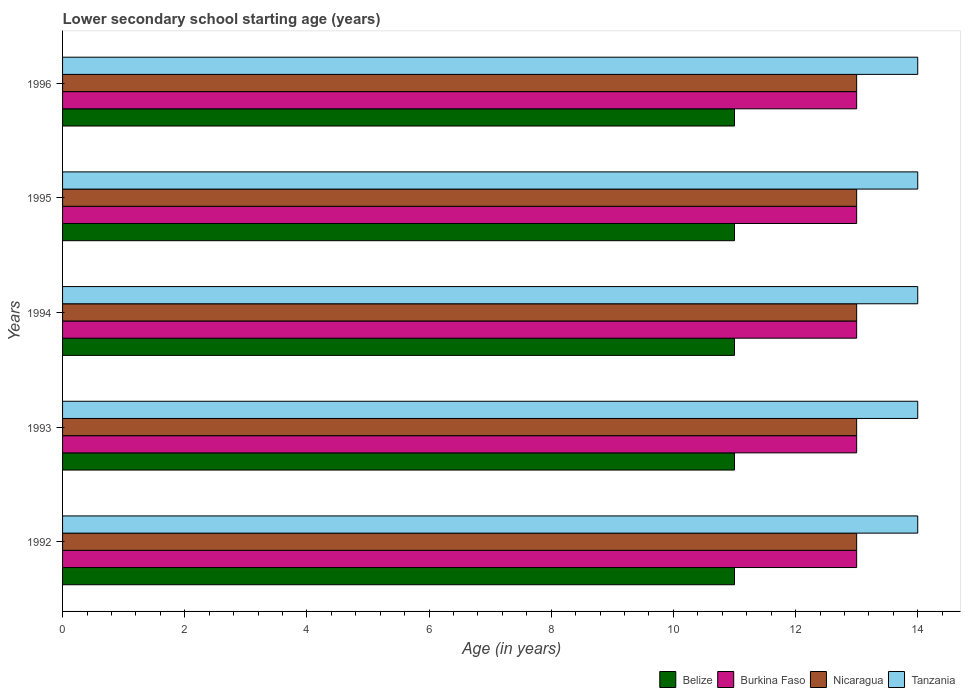How many groups of bars are there?
Your answer should be very brief. 5. Are the number of bars per tick equal to the number of legend labels?
Keep it short and to the point. Yes. Are the number of bars on each tick of the Y-axis equal?
Your response must be concise. Yes. What is the label of the 2nd group of bars from the top?
Ensure brevity in your answer.  1995. What is the lower secondary school starting age of children in Burkina Faso in 1995?
Ensure brevity in your answer.  13. Across all years, what is the maximum lower secondary school starting age of children in Belize?
Keep it short and to the point. 11. Across all years, what is the minimum lower secondary school starting age of children in Nicaragua?
Offer a terse response. 13. In which year was the lower secondary school starting age of children in Burkina Faso maximum?
Provide a succinct answer. 1992. In which year was the lower secondary school starting age of children in Belize minimum?
Your answer should be very brief. 1992. What is the total lower secondary school starting age of children in Nicaragua in the graph?
Offer a terse response. 65. What is the difference between the lower secondary school starting age of children in Belize in 1992 and that in 1994?
Offer a very short reply. 0. What is the difference between the lower secondary school starting age of children in Burkina Faso in 1993 and the lower secondary school starting age of children in Nicaragua in 1996?
Your answer should be very brief. 0. In the year 1995, what is the difference between the lower secondary school starting age of children in Burkina Faso and lower secondary school starting age of children in Tanzania?
Offer a very short reply. -1. What is the ratio of the lower secondary school starting age of children in Belize in 1993 to that in 1994?
Provide a short and direct response. 1. Is the lower secondary school starting age of children in Burkina Faso in 1994 less than that in 1996?
Provide a short and direct response. No. Is the difference between the lower secondary school starting age of children in Burkina Faso in 1993 and 1995 greater than the difference between the lower secondary school starting age of children in Tanzania in 1993 and 1995?
Offer a terse response. No. What is the difference between the highest and the lowest lower secondary school starting age of children in Burkina Faso?
Your answer should be very brief. 0. Is it the case that in every year, the sum of the lower secondary school starting age of children in Nicaragua and lower secondary school starting age of children in Belize is greater than the sum of lower secondary school starting age of children in Tanzania and lower secondary school starting age of children in Burkina Faso?
Ensure brevity in your answer.  No. What does the 3rd bar from the top in 1993 represents?
Offer a very short reply. Burkina Faso. What does the 1st bar from the bottom in 1993 represents?
Keep it short and to the point. Belize. How many bars are there?
Your answer should be very brief. 20. How many years are there in the graph?
Provide a short and direct response. 5. Are the values on the major ticks of X-axis written in scientific E-notation?
Provide a succinct answer. No. Does the graph contain any zero values?
Offer a terse response. No. Does the graph contain grids?
Make the answer very short. No. What is the title of the graph?
Provide a short and direct response. Lower secondary school starting age (years). Does "Yemen, Rep." appear as one of the legend labels in the graph?
Your answer should be compact. No. What is the label or title of the X-axis?
Your answer should be very brief. Age (in years). What is the label or title of the Y-axis?
Your answer should be compact. Years. What is the Age (in years) in Tanzania in 1992?
Make the answer very short. 14. What is the Age (in years) of Belize in 1993?
Ensure brevity in your answer.  11. What is the Age (in years) in Nicaragua in 1993?
Give a very brief answer. 13. What is the Age (in years) of Nicaragua in 1994?
Ensure brevity in your answer.  13. What is the Age (in years) of Nicaragua in 1995?
Your response must be concise. 13. What is the Age (in years) in Tanzania in 1995?
Keep it short and to the point. 14. What is the Age (in years) in Belize in 1996?
Your answer should be compact. 11. What is the Age (in years) of Tanzania in 1996?
Provide a short and direct response. 14. Across all years, what is the maximum Age (in years) of Belize?
Offer a terse response. 11. Across all years, what is the maximum Age (in years) in Nicaragua?
Your answer should be compact. 13. Across all years, what is the maximum Age (in years) of Tanzania?
Make the answer very short. 14. Across all years, what is the minimum Age (in years) of Belize?
Provide a succinct answer. 11. Across all years, what is the minimum Age (in years) of Burkina Faso?
Offer a terse response. 13. Across all years, what is the minimum Age (in years) of Nicaragua?
Offer a very short reply. 13. What is the total Age (in years) of Burkina Faso in the graph?
Give a very brief answer. 65. What is the total Age (in years) of Tanzania in the graph?
Your response must be concise. 70. What is the difference between the Age (in years) of Belize in 1992 and that in 1993?
Provide a succinct answer. 0. What is the difference between the Age (in years) in Tanzania in 1992 and that in 1993?
Provide a succinct answer. 0. What is the difference between the Age (in years) in Nicaragua in 1992 and that in 1994?
Your answer should be very brief. 0. What is the difference between the Age (in years) of Belize in 1992 and that in 1995?
Provide a succinct answer. 0. What is the difference between the Age (in years) of Tanzania in 1992 and that in 1995?
Ensure brevity in your answer.  0. What is the difference between the Age (in years) in Belize in 1992 and that in 1996?
Provide a succinct answer. 0. What is the difference between the Age (in years) in Burkina Faso in 1992 and that in 1996?
Provide a succinct answer. 0. What is the difference between the Age (in years) in Nicaragua in 1992 and that in 1996?
Offer a terse response. 0. What is the difference between the Age (in years) in Tanzania in 1992 and that in 1996?
Your answer should be compact. 0. What is the difference between the Age (in years) in Nicaragua in 1993 and that in 1994?
Provide a short and direct response. 0. What is the difference between the Age (in years) of Burkina Faso in 1993 and that in 1995?
Keep it short and to the point. 0. What is the difference between the Age (in years) in Belize in 1994 and that in 1995?
Ensure brevity in your answer.  0. What is the difference between the Age (in years) of Burkina Faso in 1994 and that in 1995?
Ensure brevity in your answer.  0. What is the difference between the Age (in years) in Nicaragua in 1994 and that in 1995?
Offer a very short reply. 0. What is the difference between the Age (in years) in Belize in 1994 and that in 1996?
Offer a very short reply. 0. What is the difference between the Age (in years) of Tanzania in 1994 and that in 1996?
Ensure brevity in your answer.  0. What is the difference between the Age (in years) of Burkina Faso in 1995 and that in 1996?
Provide a succinct answer. 0. What is the difference between the Age (in years) in Nicaragua in 1995 and that in 1996?
Your answer should be very brief. 0. What is the difference between the Age (in years) of Tanzania in 1995 and that in 1996?
Your answer should be very brief. 0. What is the difference between the Age (in years) in Belize in 1992 and the Age (in years) in Burkina Faso in 1993?
Ensure brevity in your answer.  -2. What is the difference between the Age (in years) of Burkina Faso in 1992 and the Age (in years) of Nicaragua in 1993?
Offer a very short reply. 0. What is the difference between the Age (in years) in Burkina Faso in 1992 and the Age (in years) in Tanzania in 1993?
Your answer should be very brief. -1. What is the difference between the Age (in years) of Belize in 1992 and the Age (in years) of Burkina Faso in 1994?
Make the answer very short. -2. What is the difference between the Age (in years) of Belize in 1992 and the Age (in years) of Tanzania in 1994?
Give a very brief answer. -3. What is the difference between the Age (in years) in Burkina Faso in 1992 and the Age (in years) in Nicaragua in 1994?
Keep it short and to the point. 0. What is the difference between the Age (in years) of Burkina Faso in 1992 and the Age (in years) of Tanzania in 1994?
Your response must be concise. -1. What is the difference between the Age (in years) of Nicaragua in 1992 and the Age (in years) of Tanzania in 1994?
Offer a terse response. -1. What is the difference between the Age (in years) of Burkina Faso in 1992 and the Age (in years) of Tanzania in 1995?
Provide a short and direct response. -1. What is the difference between the Age (in years) in Belize in 1992 and the Age (in years) in Burkina Faso in 1996?
Ensure brevity in your answer.  -2. What is the difference between the Age (in years) of Burkina Faso in 1992 and the Age (in years) of Nicaragua in 1996?
Your answer should be compact. 0. What is the difference between the Age (in years) of Nicaragua in 1992 and the Age (in years) of Tanzania in 1996?
Your answer should be very brief. -1. What is the difference between the Age (in years) of Belize in 1993 and the Age (in years) of Burkina Faso in 1994?
Make the answer very short. -2. What is the difference between the Age (in years) in Belize in 1993 and the Age (in years) in Nicaragua in 1994?
Your answer should be compact. -2. What is the difference between the Age (in years) of Belize in 1993 and the Age (in years) of Tanzania in 1994?
Give a very brief answer. -3. What is the difference between the Age (in years) in Burkina Faso in 1993 and the Age (in years) in Tanzania in 1994?
Give a very brief answer. -1. What is the difference between the Age (in years) of Nicaragua in 1993 and the Age (in years) of Tanzania in 1994?
Keep it short and to the point. -1. What is the difference between the Age (in years) in Belize in 1993 and the Age (in years) in Burkina Faso in 1995?
Offer a terse response. -2. What is the difference between the Age (in years) in Burkina Faso in 1993 and the Age (in years) in Tanzania in 1995?
Provide a succinct answer. -1. What is the difference between the Age (in years) of Nicaragua in 1993 and the Age (in years) of Tanzania in 1995?
Offer a very short reply. -1. What is the difference between the Age (in years) of Belize in 1993 and the Age (in years) of Tanzania in 1996?
Your answer should be compact. -3. What is the difference between the Age (in years) of Burkina Faso in 1993 and the Age (in years) of Nicaragua in 1996?
Make the answer very short. 0. What is the difference between the Age (in years) in Burkina Faso in 1993 and the Age (in years) in Tanzania in 1996?
Give a very brief answer. -1. What is the difference between the Age (in years) of Nicaragua in 1993 and the Age (in years) of Tanzania in 1996?
Your response must be concise. -1. What is the difference between the Age (in years) of Belize in 1994 and the Age (in years) of Burkina Faso in 1995?
Your answer should be compact. -2. What is the difference between the Age (in years) of Belize in 1994 and the Age (in years) of Nicaragua in 1995?
Your answer should be very brief. -2. What is the difference between the Age (in years) of Belize in 1994 and the Age (in years) of Tanzania in 1995?
Provide a succinct answer. -3. What is the difference between the Age (in years) of Belize in 1994 and the Age (in years) of Burkina Faso in 1996?
Your answer should be compact. -2. What is the difference between the Age (in years) of Belize in 1994 and the Age (in years) of Nicaragua in 1996?
Offer a very short reply. -2. What is the difference between the Age (in years) in Belize in 1994 and the Age (in years) in Tanzania in 1996?
Keep it short and to the point. -3. What is the difference between the Age (in years) of Burkina Faso in 1994 and the Age (in years) of Nicaragua in 1996?
Make the answer very short. 0. What is the difference between the Age (in years) of Belize in 1995 and the Age (in years) of Nicaragua in 1996?
Your answer should be very brief. -2. What is the difference between the Age (in years) of Burkina Faso in 1995 and the Age (in years) of Nicaragua in 1996?
Give a very brief answer. 0. What is the difference between the Age (in years) of Burkina Faso in 1995 and the Age (in years) of Tanzania in 1996?
Give a very brief answer. -1. What is the difference between the Age (in years) of Nicaragua in 1995 and the Age (in years) of Tanzania in 1996?
Provide a succinct answer. -1. What is the average Age (in years) in Tanzania per year?
Keep it short and to the point. 14. In the year 1992, what is the difference between the Age (in years) of Belize and Age (in years) of Burkina Faso?
Provide a succinct answer. -2. In the year 1992, what is the difference between the Age (in years) in Belize and Age (in years) in Tanzania?
Make the answer very short. -3. In the year 1992, what is the difference between the Age (in years) in Burkina Faso and Age (in years) in Nicaragua?
Keep it short and to the point. 0. In the year 1993, what is the difference between the Age (in years) of Belize and Age (in years) of Nicaragua?
Give a very brief answer. -2. In the year 1993, what is the difference between the Age (in years) of Burkina Faso and Age (in years) of Nicaragua?
Your answer should be compact. 0. In the year 1993, what is the difference between the Age (in years) of Burkina Faso and Age (in years) of Tanzania?
Keep it short and to the point. -1. In the year 1993, what is the difference between the Age (in years) in Nicaragua and Age (in years) in Tanzania?
Provide a succinct answer. -1. In the year 1994, what is the difference between the Age (in years) of Belize and Age (in years) of Nicaragua?
Make the answer very short. -2. In the year 1994, what is the difference between the Age (in years) of Belize and Age (in years) of Tanzania?
Your response must be concise. -3. In the year 1995, what is the difference between the Age (in years) in Belize and Age (in years) in Burkina Faso?
Your response must be concise. -2. In the year 1995, what is the difference between the Age (in years) of Belize and Age (in years) of Tanzania?
Your answer should be compact. -3. In the year 1995, what is the difference between the Age (in years) of Burkina Faso and Age (in years) of Tanzania?
Keep it short and to the point. -1. In the year 1996, what is the difference between the Age (in years) in Belize and Age (in years) in Burkina Faso?
Offer a terse response. -2. In the year 1996, what is the difference between the Age (in years) in Belize and Age (in years) in Nicaragua?
Make the answer very short. -2. In the year 1996, what is the difference between the Age (in years) in Burkina Faso and Age (in years) in Nicaragua?
Keep it short and to the point. 0. In the year 1996, what is the difference between the Age (in years) of Nicaragua and Age (in years) of Tanzania?
Your response must be concise. -1. What is the ratio of the Age (in years) of Burkina Faso in 1992 to that in 1993?
Your response must be concise. 1. What is the ratio of the Age (in years) in Nicaragua in 1992 to that in 1995?
Make the answer very short. 1. What is the ratio of the Age (in years) of Tanzania in 1992 to that in 1995?
Provide a succinct answer. 1. What is the ratio of the Age (in years) in Belize in 1992 to that in 1996?
Your answer should be compact. 1. What is the ratio of the Age (in years) in Burkina Faso in 1992 to that in 1996?
Offer a very short reply. 1. What is the ratio of the Age (in years) of Tanzania in 1992 to that in 1996?
Offer a terse response. 1. What is the ratio of the Age (in years) in Burkina Faso in 1993 to that in 1994?
Your answer should be compact. 1. What is the ratio of the Age (in years) in Tanzania in 1993 to that in 1994?
Provide a succinct answer. 1. What is the ratio of the Age (in years) in Belize in 1993 to that in 1995?
Your answer should be very brief. 1. What is the ratio of the Age (in years) in Nicaragua in 1993 to that in 1995?
Ensure brevity in your answer.  1. What is the ratio of the Age (in years) in Tanzania in 1993 to that in 1995?
Give a very brief answer. 1. What is the ratio of the Age (in years) in Belize in 1993 to that in 1996?
Your response must be concise. 1. What is the ratio of the Age (in years) of Burkina Faso in 1993 to that in 1996?
Offer a terse response. 1. What is the ratio of the Age (in years) in Nicaragua in 1993 to that in 1996?
Keep it short and to the point. 1. What is the ratio of the Age (in years) in Burkina Faso in 1994 to that in 1995?
Your answer should be very brief. 1. What is the ratio of the Age (in years) in Nicaragua in 1994 to that in 1995?
Your answer should be compact. 1. What is the ratio of the Age (in years) of Belize in 1994 to that in 1996?
Provide a short and direct response. 1. What is the ratio of the Age (in years) of Nicaragua in 1994 to that in 1996?
Offer a terse response. 1. What is the ratio of the Age (in years) of Tanzania in 1994 to that in 1996?
Make the answer very short. 1. What is the ratio of the Age (in years) of Belize in 1995 to that in 1996?
Offer a very short reply. 1. What is the ratio of the Age (in years) in Tanzania in 1995 to that in 1996?
Your answer should be very brief. 1. What is the difference between the highest and the second highest Age (in years) of Belize?
Your response must be concise. 0. What is the difference between the highest and the second highest Age (in years) in Nicaragua?
Your answer should be compact. 0. What is the difference between the highest and the lowest Age (in years) in Belize?
Give a very brief answer. 0. What is the difference between the highest and the lowest Age (in years) in Nicaragua?
Offer a very short reply. 0. What is the difference between the highest and the lowest Age (in years) of Tanzania?
Provide a succinct answer. 0. 